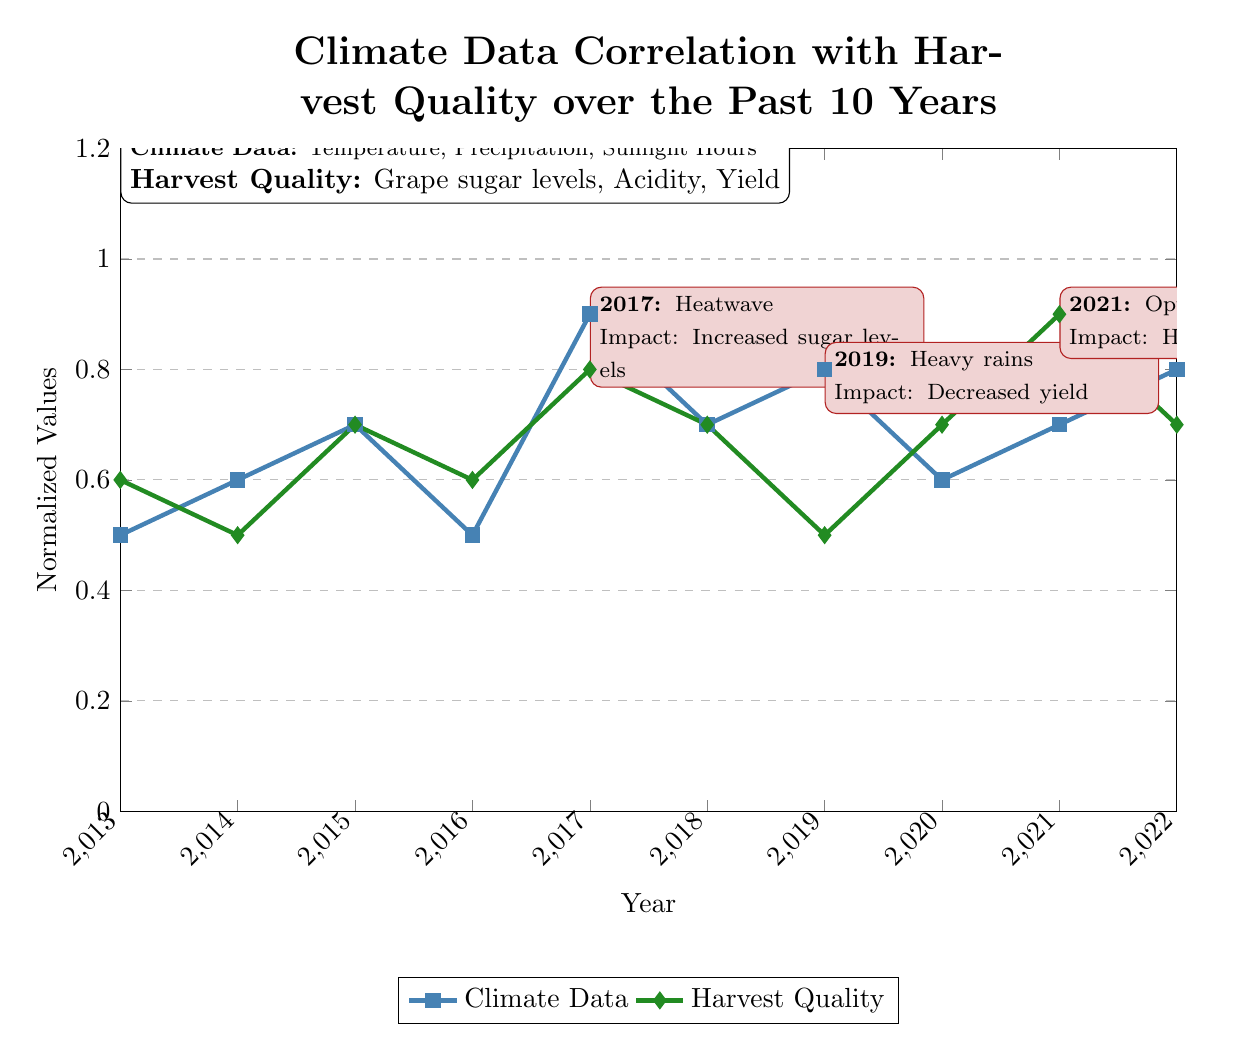What is the highest climate data value recorded in the diagram? The diagram indicates that the highest climate data value is at the year 2017, with a normalized value of 0.9. This can be confirmed by locating the peak point of the 'Climate Data' line on the graph.
Answer: 0.9 What year corresponds to a harvest quality value of 0.5? The harvest quality value of 0.5 is identified for the year 2019 by checking the 'Harvest Quality' line in the diagram.
Answer: 2019 What event occurred in 2021, according to the annotations? The annotation states that 2021 had "Optimal conditions" which indicates favorable circumstances for grape production. This can be found by examining the note placed in that year on the graph.
Answer: Optimal conditions How did the heatwave in 2017 impact harvest quality? The explanation given in the annotation for the year 2017 notes that the impact was "Increased sugar levels," which implies that the harvest quality improved as a result of the high temperatures. This can be deduced by reading the associated annotation.
Answer: Increased sugar levels What was the average normalized value for climate data over the years shown? By summing the climate data values from each year and dividing by the number of years (10), we get an average normalized value. These values are 0.5, 0.6, 0.7, 0.5, 0.9, 0.7, 0.8, 0.6, 0.7, and 0.8, leading to an average of 0.68. Thus, the average can be computed directly from the listed values.
Answer: 0.68 Which year had the highest normalized value for harvest quality? By scanning the harvest quality values in the diagram, the highest value is found in 2021 where it reaches 0.9. This is noted by following the 'Harvest Quality' line until the peak.
Answer: 2021 What was the impact of heavy rains in 2019? The 2019 annotation states the impact was "Decreased yield," which indicates a negative effect on grape production due to adverse weather conditions. This information is available in the annotation for that particular year.
Answer: Decreased yield What was the relationship between climate data and harvest quality in 2018? The diagram displays that in 2018, climate data was at a normalized value of 0.7 while harvest quality similarly was also 0.7, indicating a direct correlation between the two measures during that year. This relationship is established by comparing both plots at the same x-coordinate in the diagram.
Answer: Equal values What does the color of the climate data line represent? The color blue is specifically used for the climate data line in the diagram as denoted by the legend. This can be directly observed in the visual representation.
Answer: Blue 